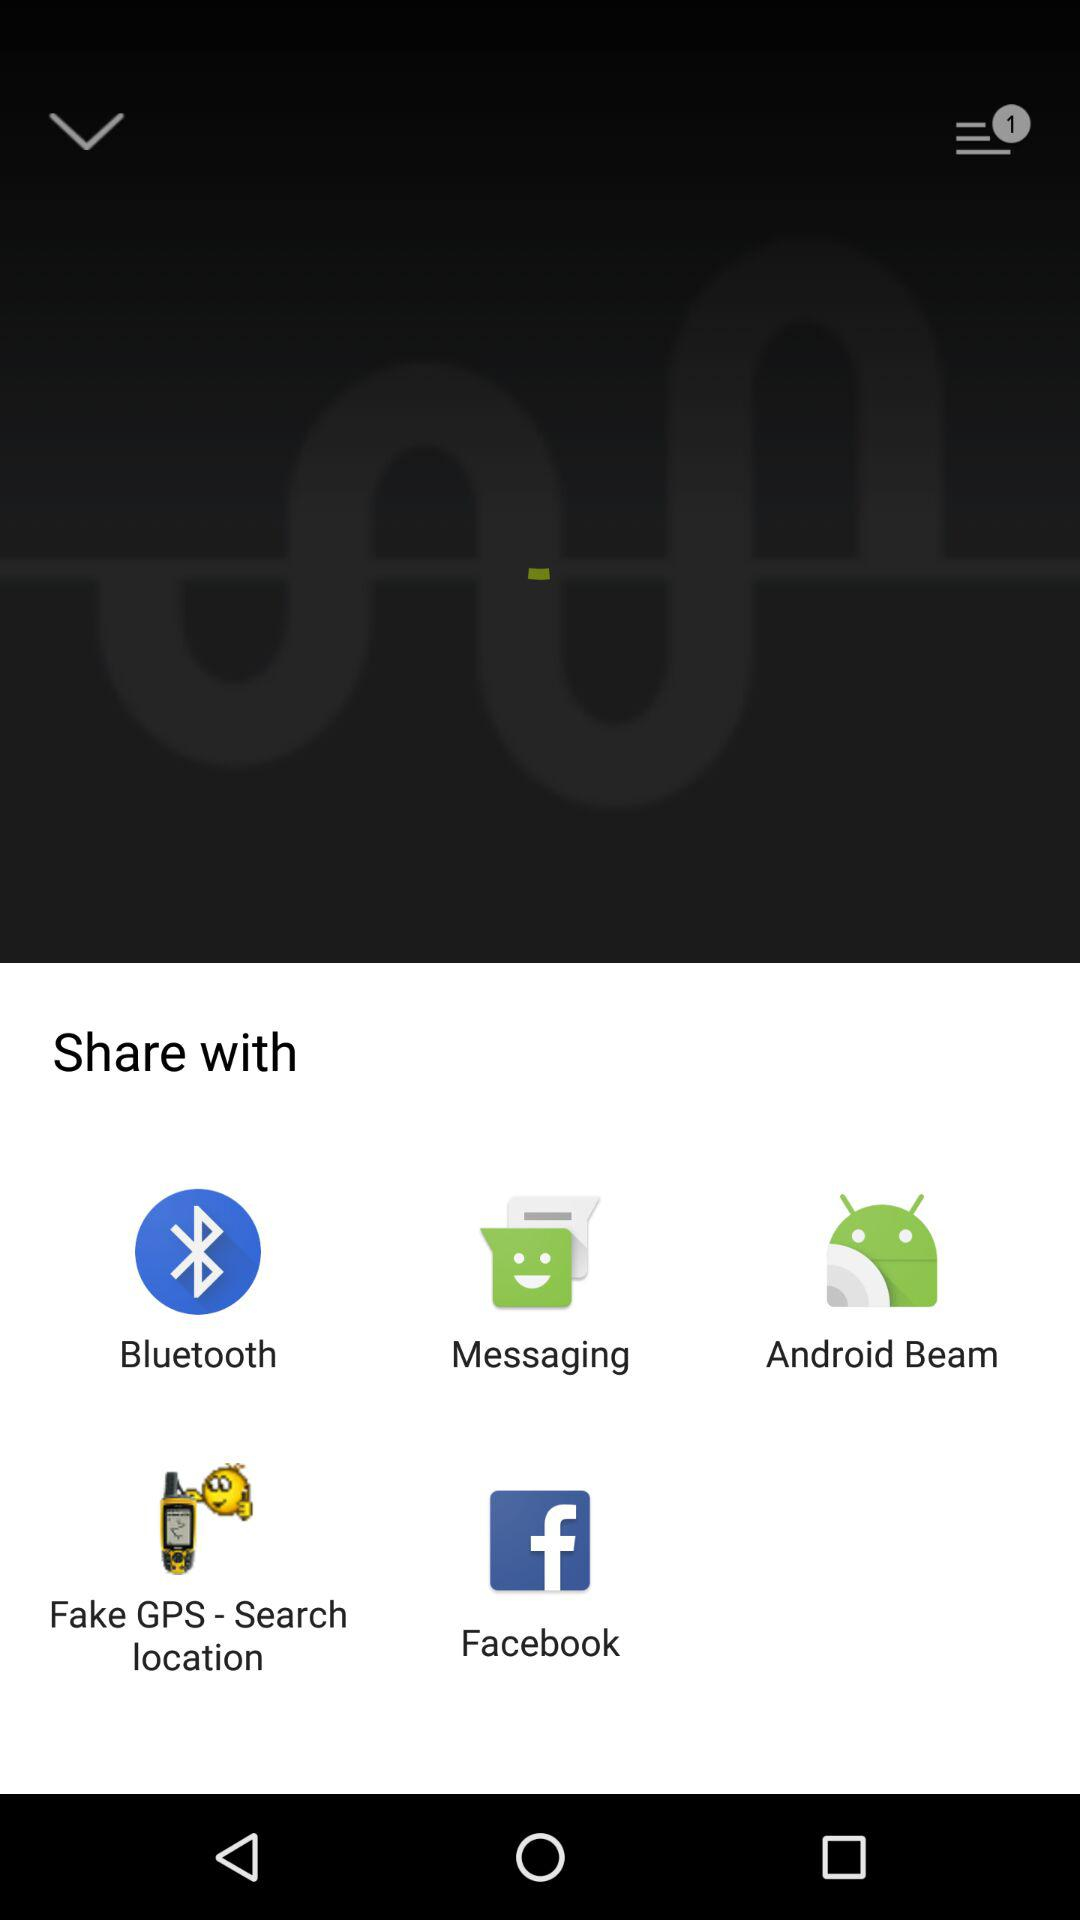Which application can be chosen to share the content? The applications "Bluetooth", "Messaging", "Android Beam", "Fake GPS - Search location" and "Facebook" can be chosen to share the content. 